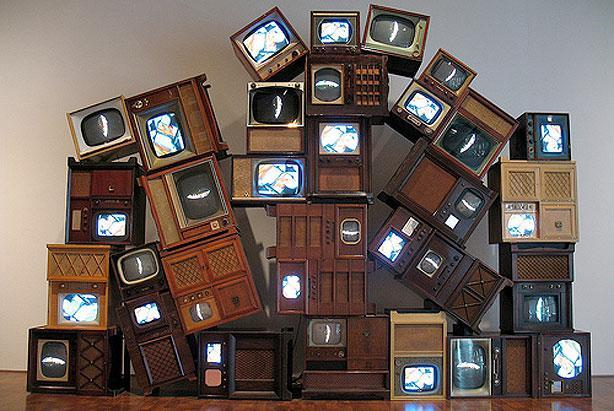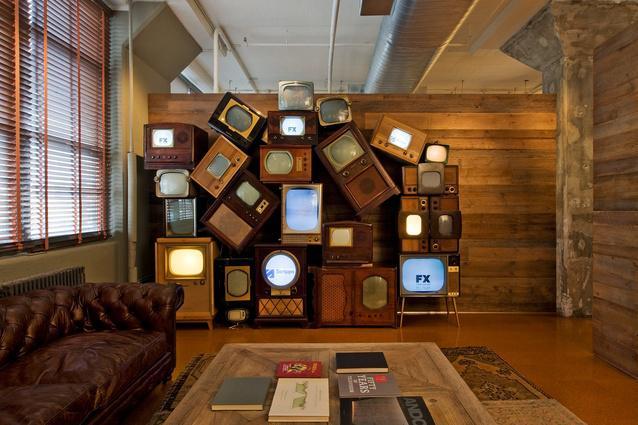The first image is the image on the left, the second image is the image on the right. Analyze the images presented: Is the assertion "There is some kind of armed seat in a room containing a stack of old-fashioned TV sets." valid? Answer yes or no. Yes. The first image is the image on the left, the second image is the image on the right. For the images shown, is this caption "A pile of old television sits in a room with a wallpapered wall behind it." true? Answer yes or no. No. 